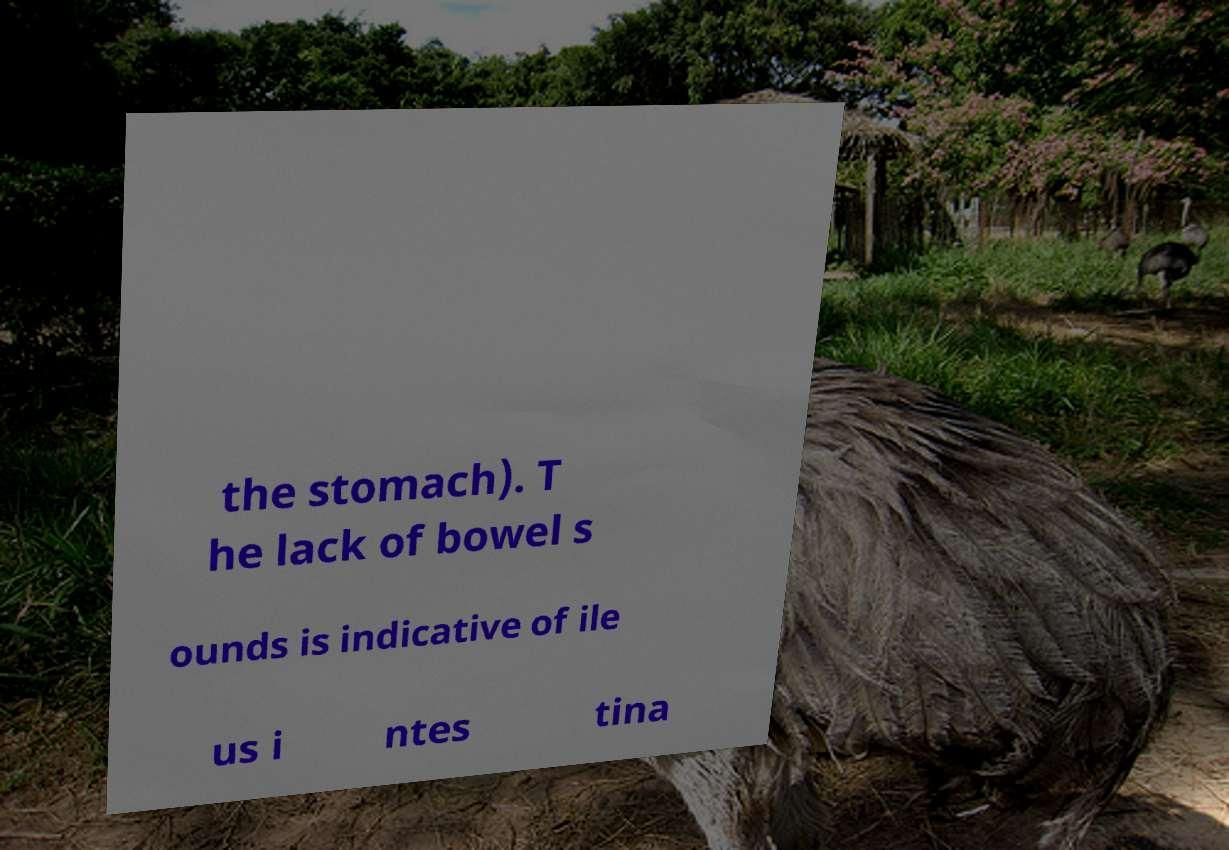There's text embedded in this image that I need extracted. Can you transcribe it verbatim? the stomach). T he lack of bowel s ounds is indicative of ile us i ntes tina 